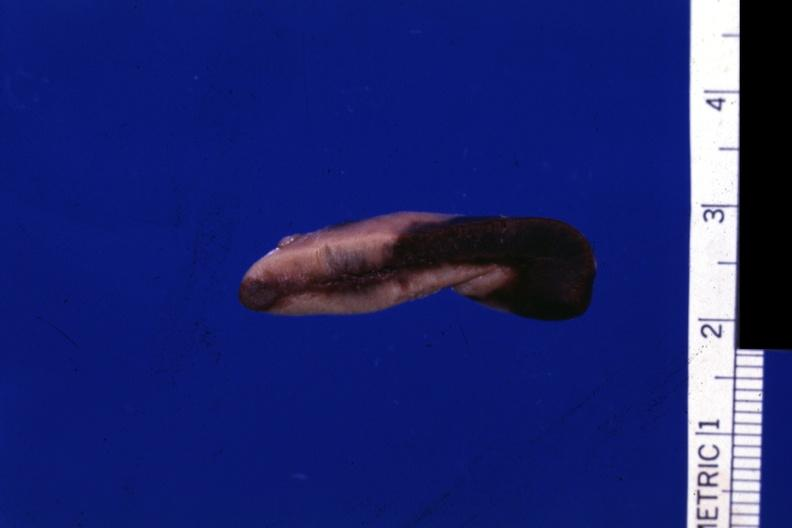does this image show fixed tissue close-up view typical early hemorrhage in cortex?
Answer the question using a single word or phrase. Yes 